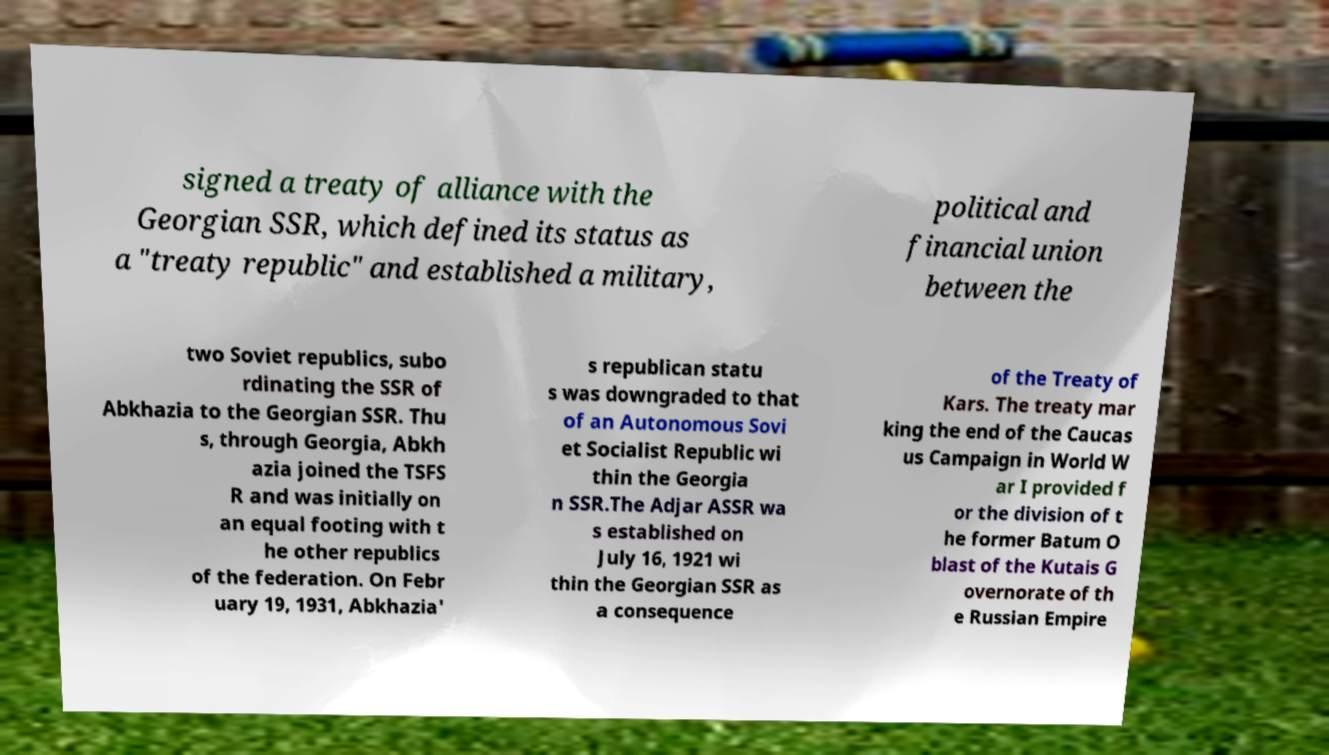Could you extract and type out the text from this image? signed a treaty of alliance with the Georgian SSR, which defined its status as a "treaty republic" and established a military, political and financial union between the two Soviet republics, subo rdinating the SSR of Abkhazia to the Georgian SSR. Thu s, through Georgia, Abkh azia joined the TSFS R and was initially on an equal footing with t he other republics of the federation. On Febr uary 19, 1931, Abkhazia' s republican statu s was downgraded to that of an Autonomous Sovi et Socialist Republic wi thin the Georgia n SSR.The Adjar ASSR wa s established on July 16, 1921 wi thin the Georgian SSR as a consequence of the Treaty of Kars. The treaty mar king the end of the Caucas us Campaign in World W ar I provided f or the division of t he former Batum O blast of the Kutais G overnorate of th e Russian Empire 